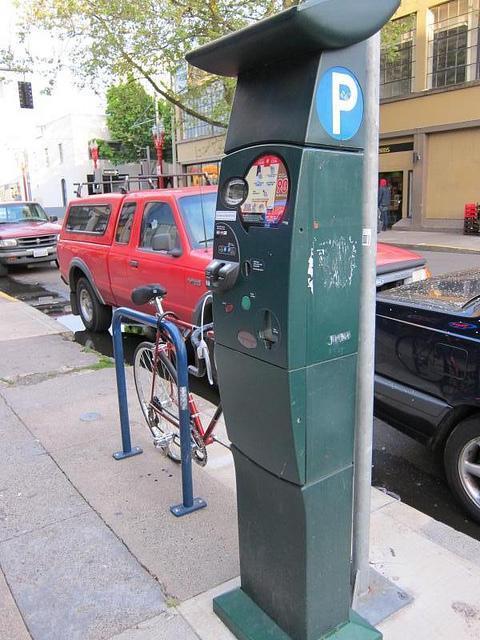How many vehicles are parked on the street?
Give a very brief answer. 3. How many bicycles are in the picture?
Give a very brief answer. 1. How many cars are in the picture?
Give a very brief answer. 3. 